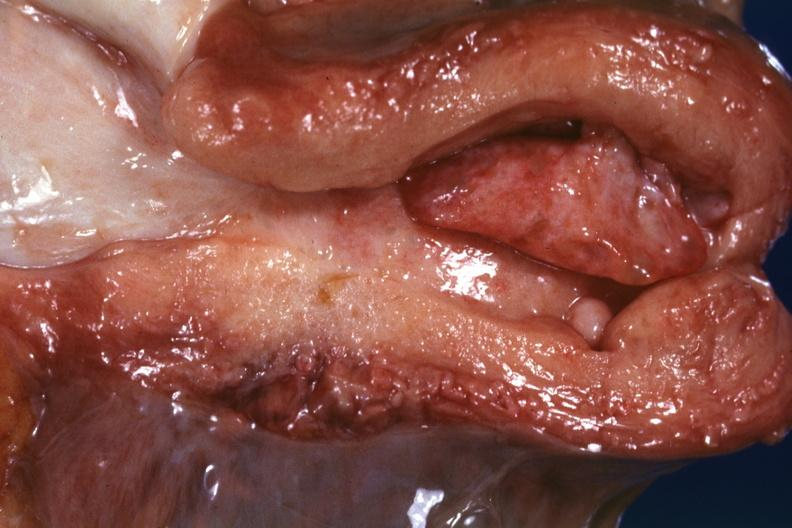s female reproductive present?
Answer the question using a single word or phrase. Yes 